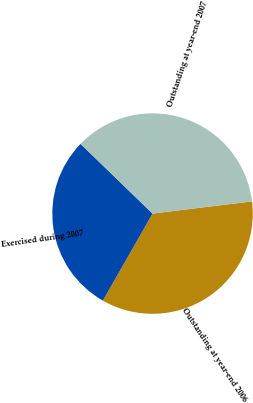Convert chart to OTSL. <chart><loc_0><loc_0><loc_500><loc_500><pie_chart><fcel>Outstanding at year-end 2006<fcel>Exercised during 2007<fcel>Outstanding at year-end 2007<nl><fcel>35.2%<fcel>28.99%<fcel>35.82%<nl></chart> 